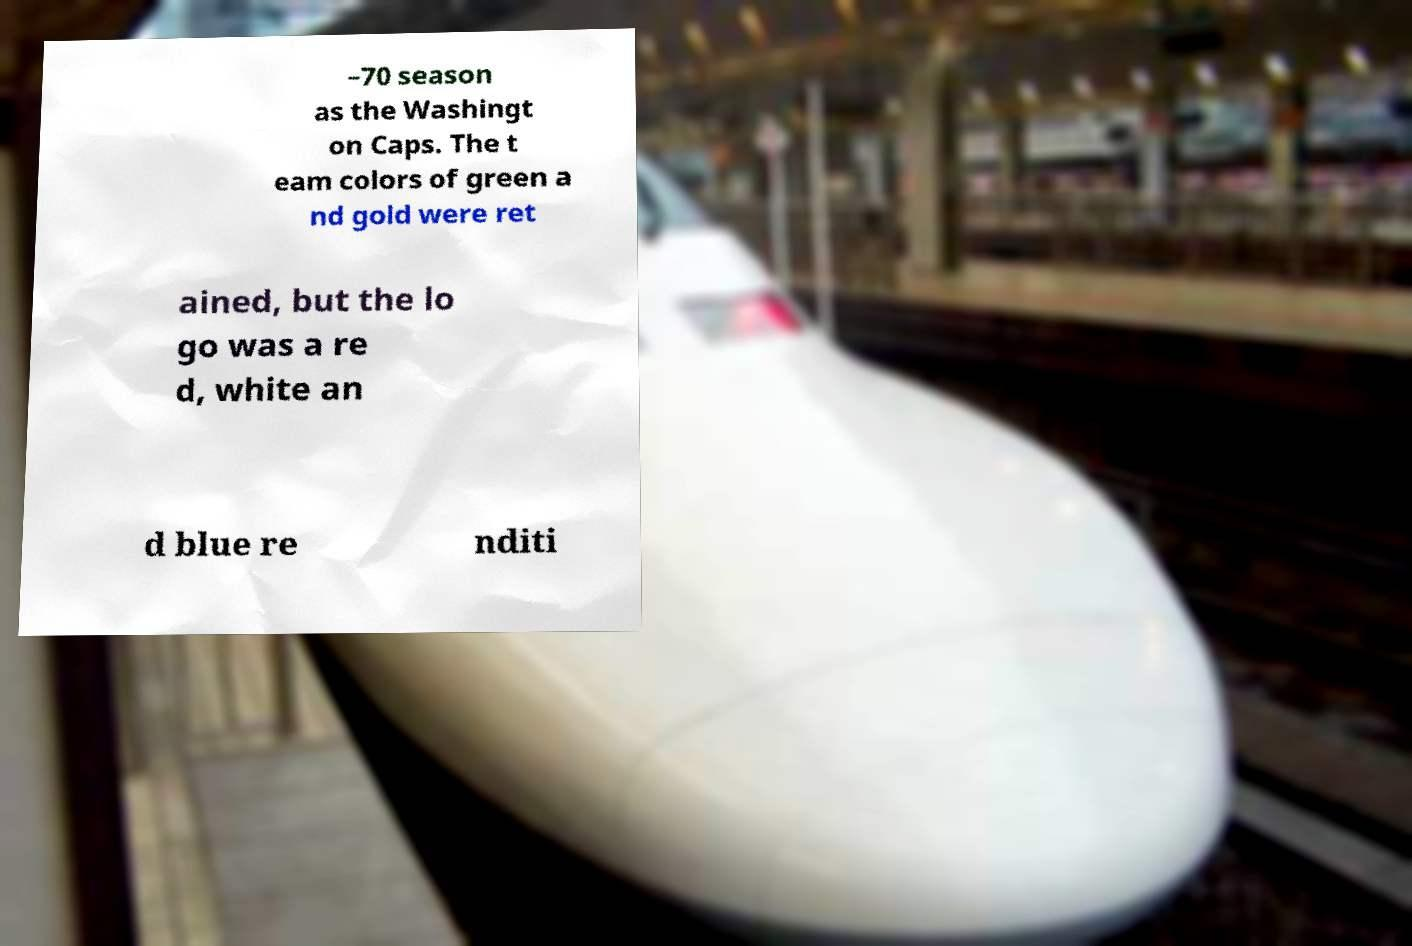Can you accurately transcribe the text from the provided image for me? –70 season as the Washingt on Caps. The t eam colors of green a nd gold were ret ained, but the lo go was a re d, white an d blue re nditi 